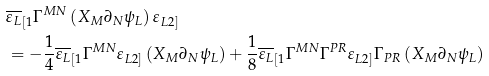<formula> <loc_0><loc_0><loc_500><loc_500>& \overline { \varepsilon _ { L } } _ { [ 1 } \Gamma ^ { M N } \left ( X _ { M } \partial _ { N } \psi _ { L } \right ) \varepsilon _ { L 2 ] } \\ & = - \frac { 1 } { 4 } \overline { \varepsilon _ { L } } _ { [ 1 } \Gamma ^ { M N } \varepsilon _ { L 2 ] } \left ( X _ { M } \partial _ { N } \psi _ { L } \right ) + \frac { 1 } { 8 } \overline { \varepsilon _ { L } } _ { [ 1 } \Gamma ^ { M N } \Gamma ^ { P R } \varepsilon _ { L 2 ] } \Gamma _ { P R } \left ( X _ { M } \partial _ { N } \psi _ { L } \right )</formula> 